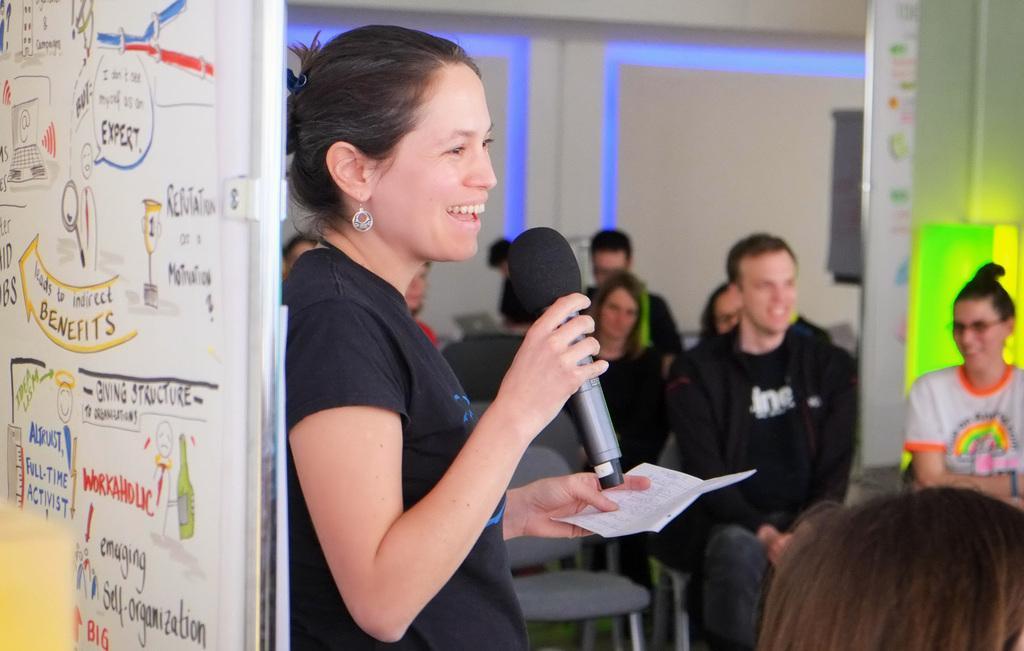How would you summarize this image in a sentence or two? In the image there is a woman stood with mic in her hand and in front of her there are few people sat on chairs, this place it seems to be classroom or a conference room and at the background there are colorful lights at wall and at the edge. 